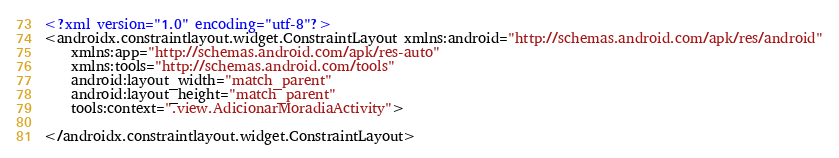<code> <loc_0><loc_0><loc_500><loc_500><_XML_><?xml version="1.0" encoding="utf-8"?>
<androidx.constraintlayout.widget.ConstraintLayout xmlns:android="http://schemas.android.com/apk/res/android"
    xmlns:app="http://schemas.android.com/apk/res-auto"
    xmlns:tools="http://schemas.android.com/tools"
    android:layout_width="match_parent"
    android:layout_height="match_parent"
    tools:context=".view.AdicionarMoradiaActivity">

</androidx.constraintlayout.widget.ConstraintLayout></code> 